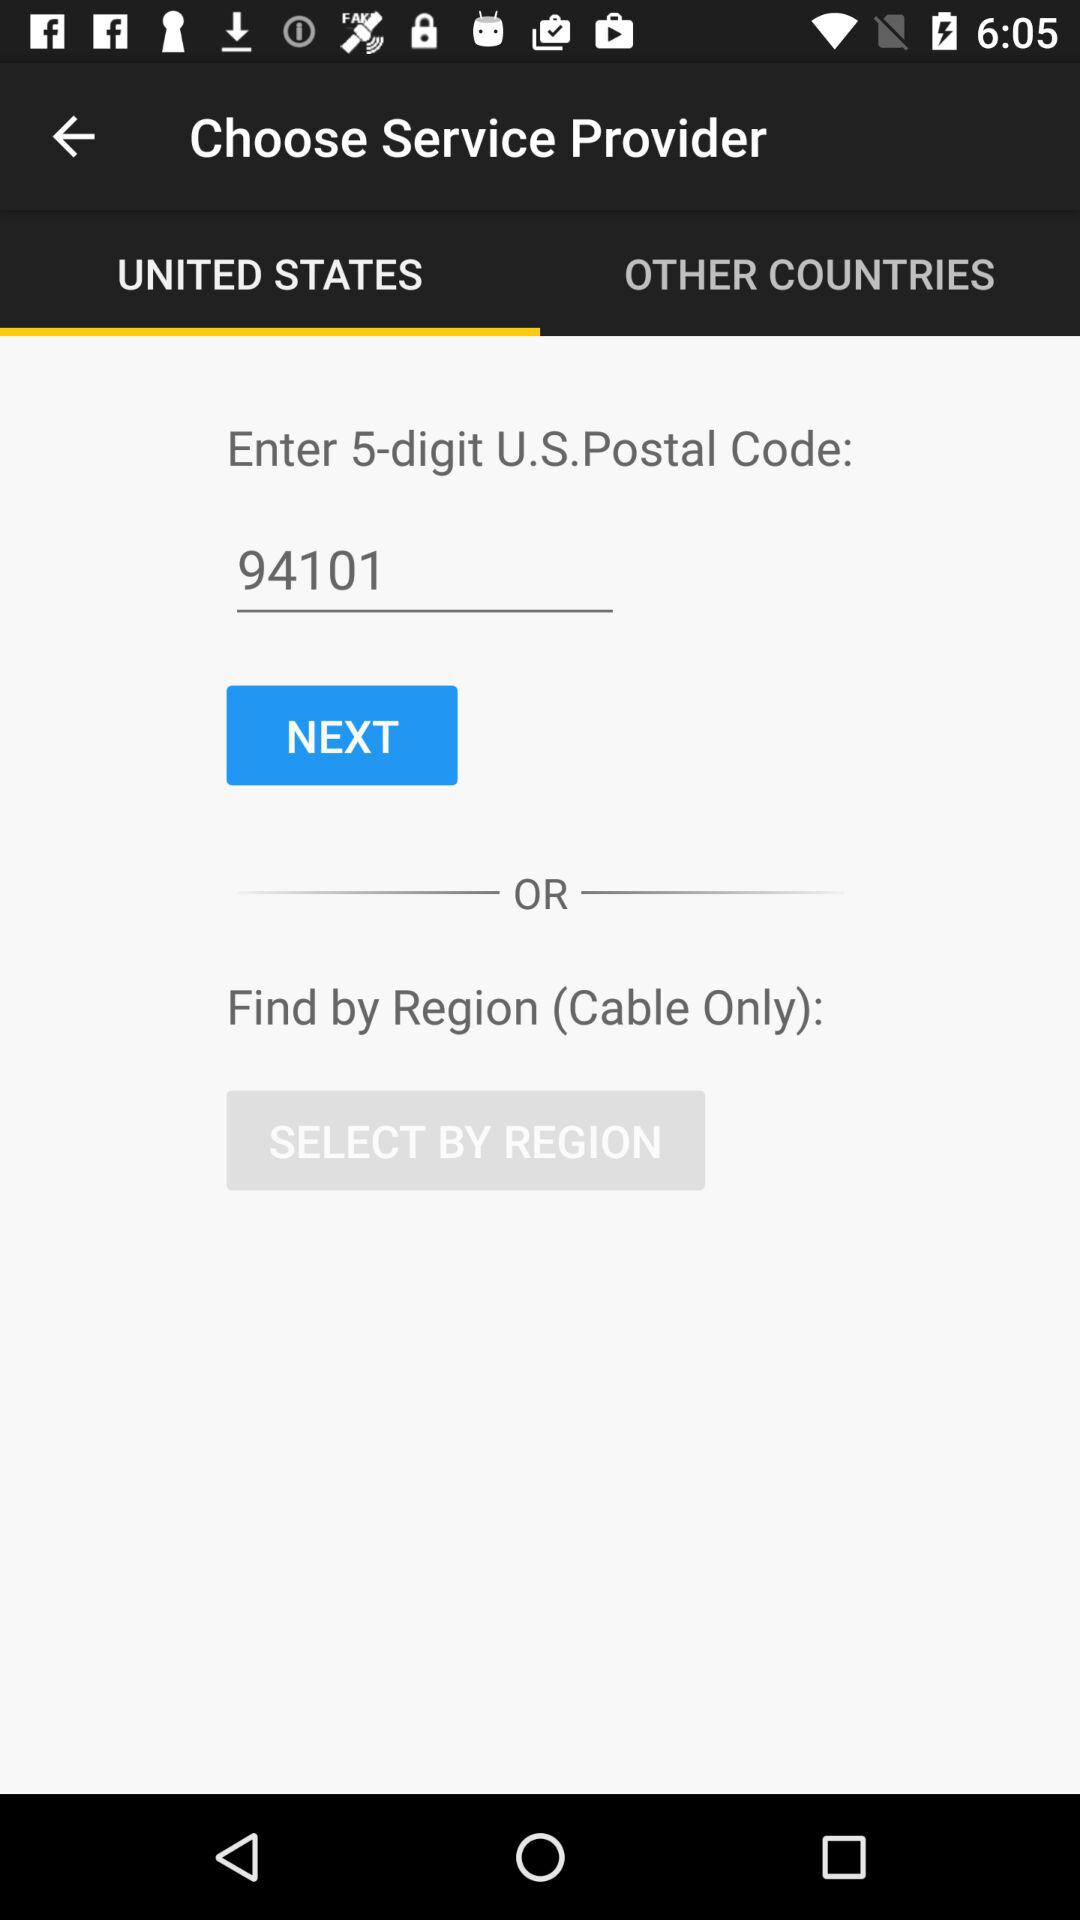Which tab has been selected? The tab "UNITED STATES" has been selected. 